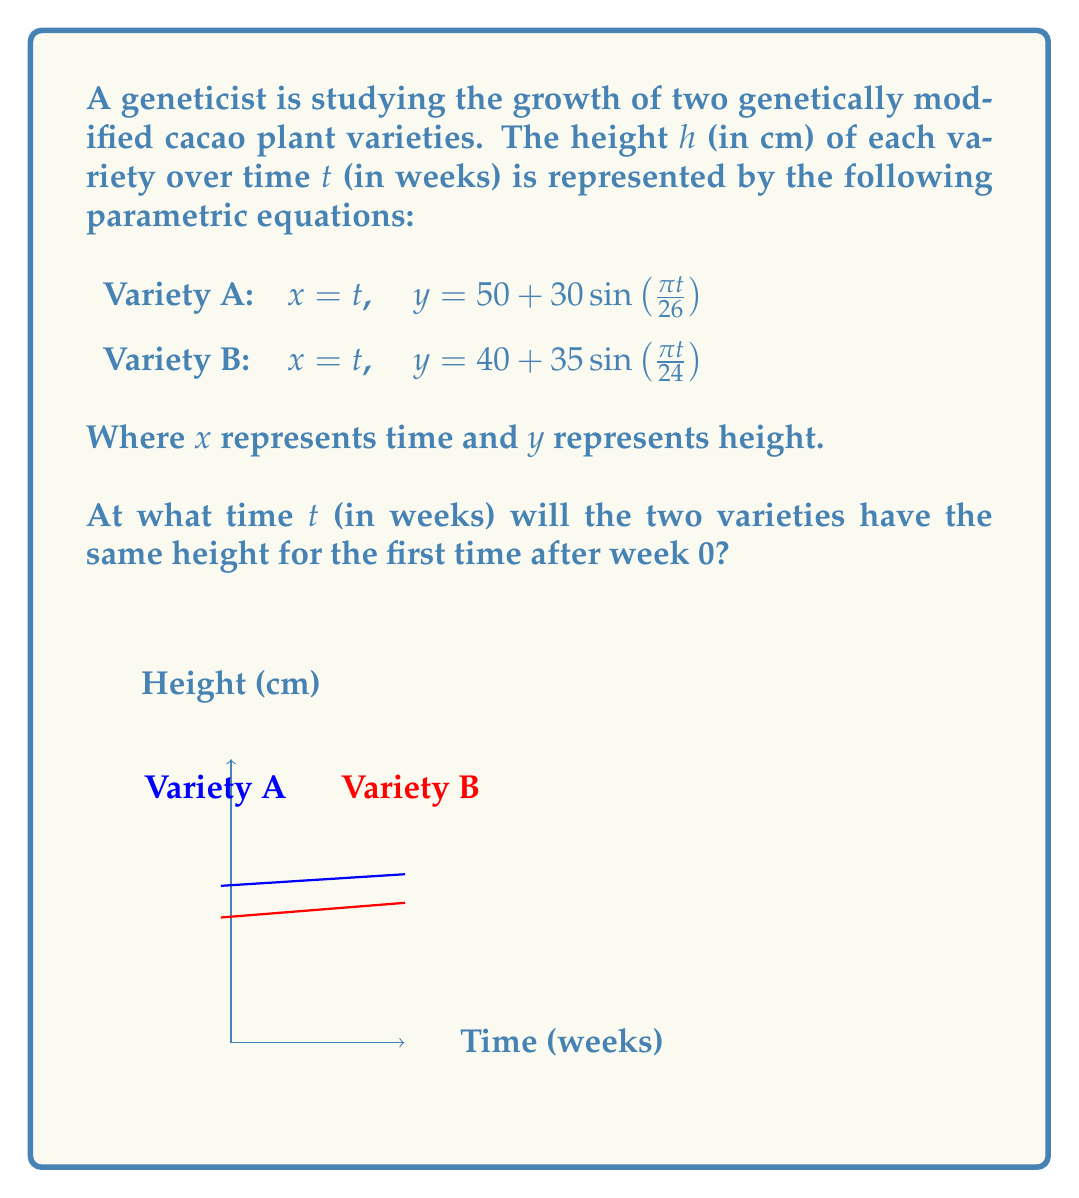Could you help me with this problem? To find when the two varieties have the same height, we need to solve the equation:

$$50 + 30\sin(\frac{\pi t}{26}) = 40 + 35\sin(\frac{\pi t}{24})$$

Let's approach this step-by-step:

1) Rearrange the equation:
   $$30\sin(\frac{\pi t}{26}) - 35\sin(\frac{\pi t}{24}) = -10$$

2) This equation is complex to solve analytically. We'll use a numerical method, specifically the bisection method.

3) First, let's define a function $f(t)$:
   $$f(t) = 30\sin(\frac{\pi t}{26}) - 35\sin(\frac{\pi t}{24}) + 10$$

4) We need to find the root of this function. Let's start with the interval [0, 52] (one year).

5) Using a calculator or computer program, we can find that:
   $f(0) = 10$ and $f(52) \approx 9.98$

6) The function changes sign between $t=12$ and $t=13$:
   $f(12) \approx 0.59$ and $f(13) \approx -0.32$

7) Applying the bisection method in the interval [12, 13]:
   At $t = 12.5$, $f(12.5) \approx 0.13$
   At $t = 12.75$, $f(12.75) \approx -0.09$

8) Continuing this process, we converge to the solution $t \approx 12.71$ weeks.

9) We can verify this by plugging it back into the original equations:
   For Variety A: $50 + 30\sin(\frac{\pi(12.71)}{26}) \approx 69.95$ cm
   For Variety B: $40 + 35\sin(\frac{\pi(12.71)}{24}) \approx 69.95$ cm

Thus, the two varieties will have the same height for the first time after week 0 at approximately 12.71 weeks.
Answer: $12.71$ weeks 